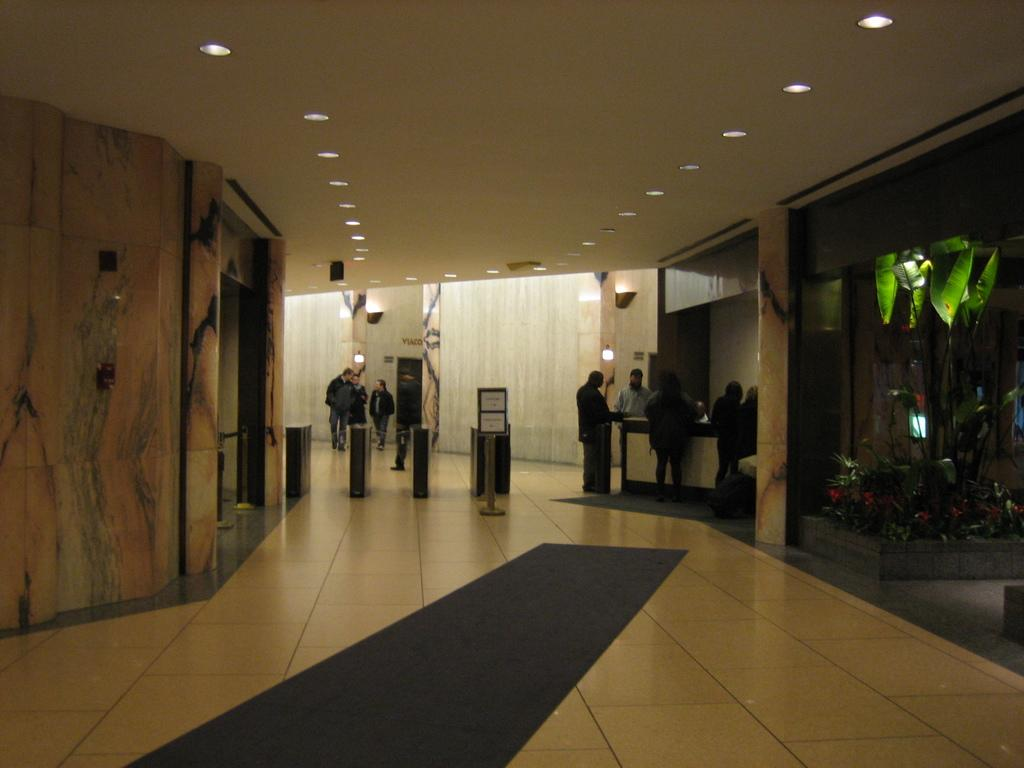What type of location is shown in the image? The image depicts an inside view of a building. Can you describe the people visible in the image? There are people visible in the image. What type of illumination is present in the image? There are lights in the image. What type of greenery is present in the image? There are plants in the image. What type of music can be heard playing in the background of the image? There is no music present in the image, as it is a still image and does not have any audible elements. 